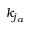<formula> <loc_0><loc_0><loc_500><loc_500>k _ { j _ { a } }</formula> 